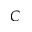Convert formula to latex. <formula><loc_0><loc_0><loc_500><loc_500>C</formula> 